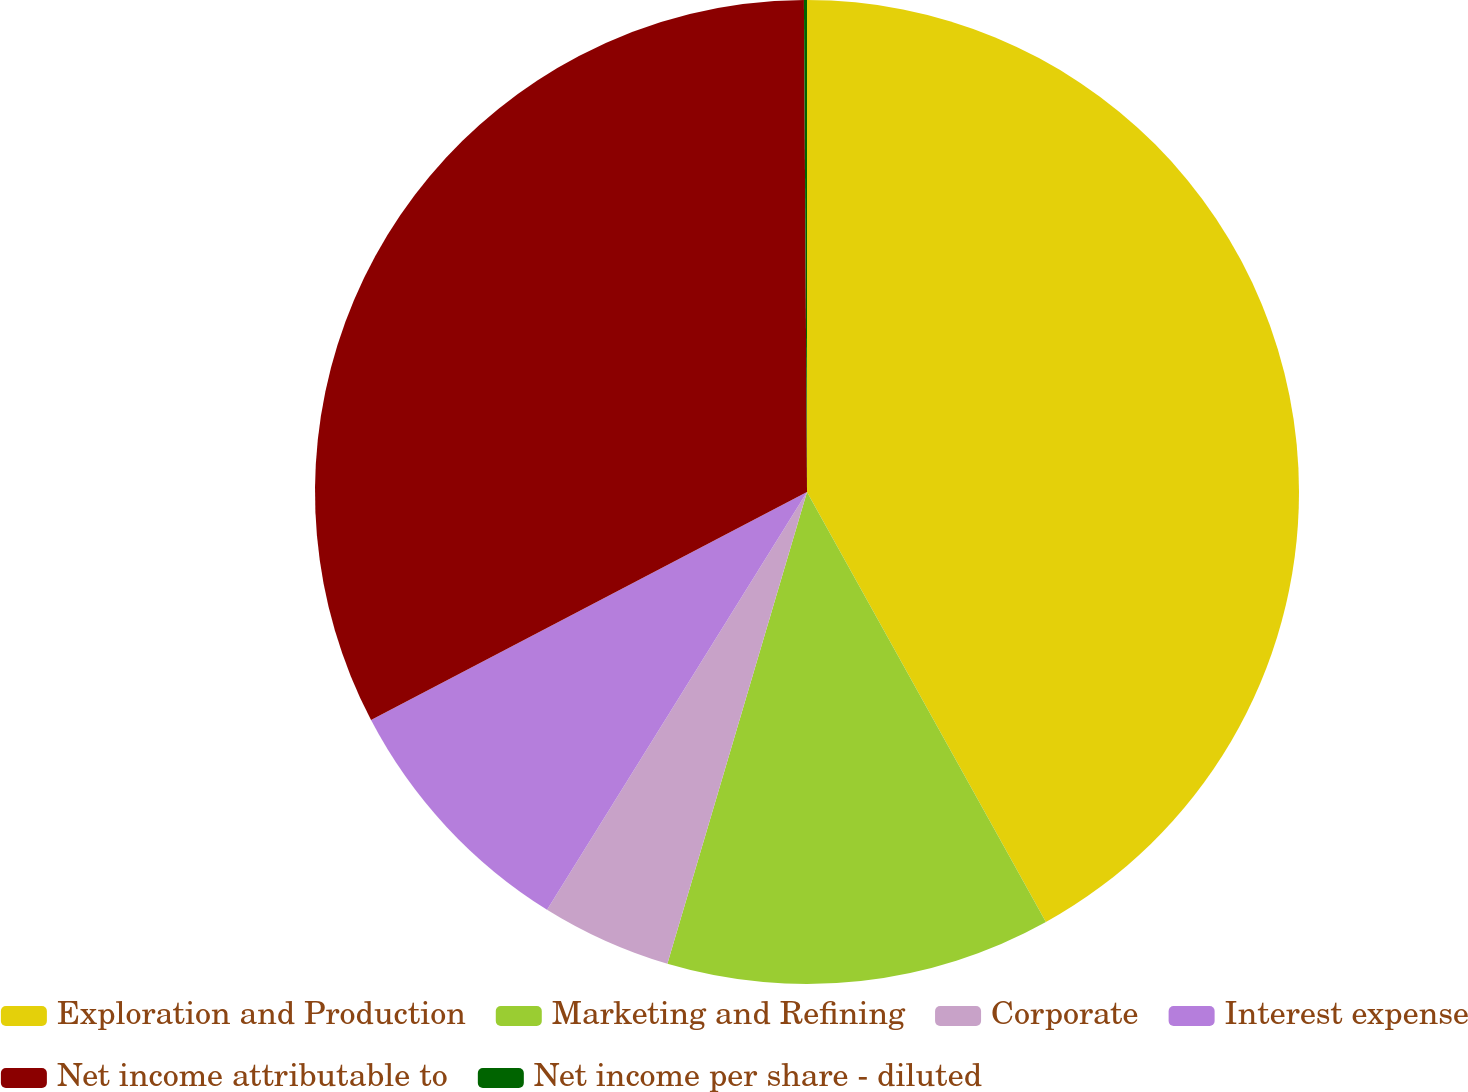<chart> <loc_0><loc_0><loc_500><loc_500><pie_chart><fcel>Exploration and Production<fcel>Marketing and Refining<fcel>Corporate<fcel>Interest expense<fcel>Net income attributable to<fcel>Net income per share - diluted<nl><fcel>41.93%<fcel>12.65%<fcel>4.28%<fcel>8.47%<fcel>32.57%<fcel>0.1%<nl></chart> 